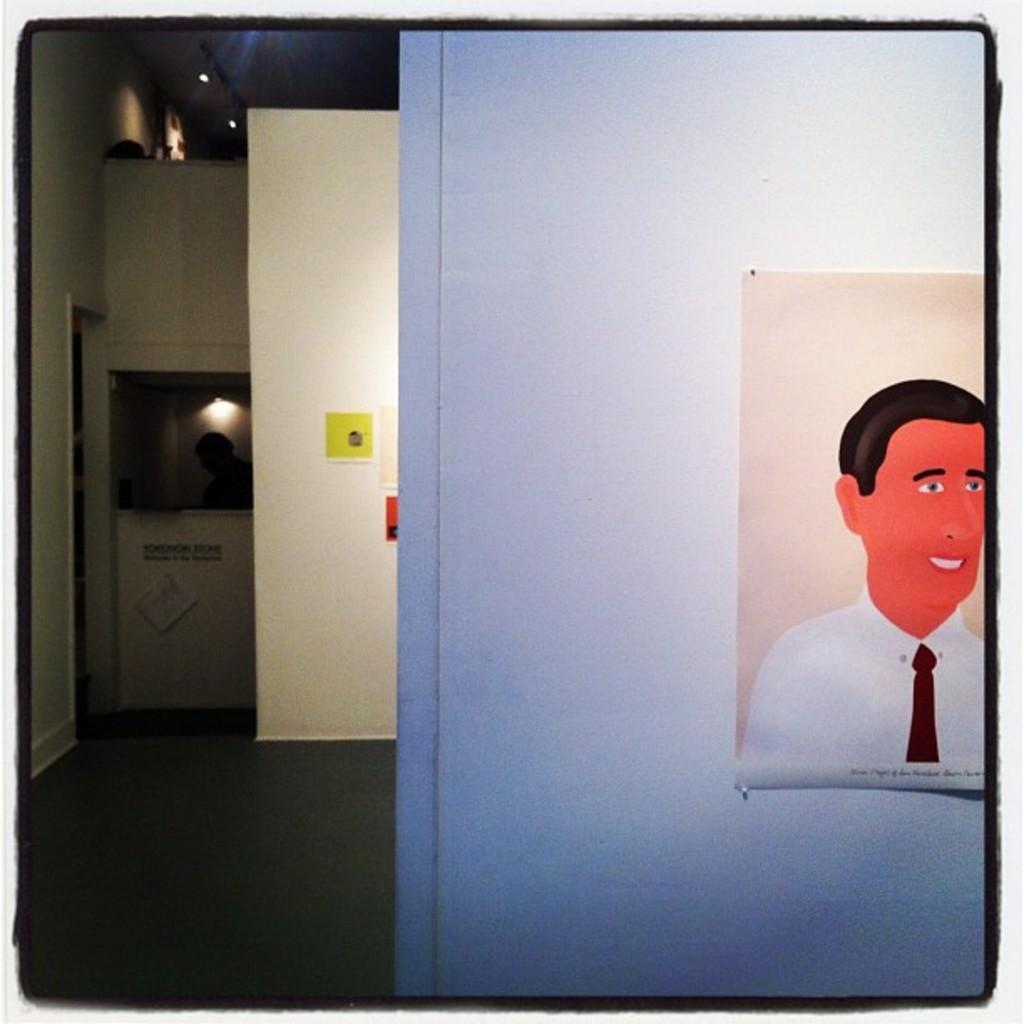Describe this image in one or two sentences. In this picture we can see few paintings, in the background we can find few lights and a person. 